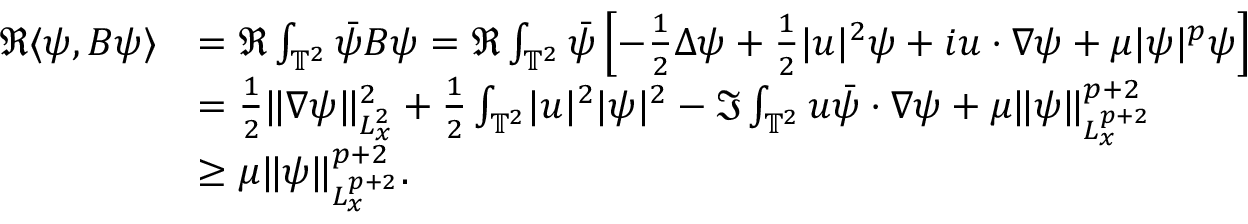<formula> <loc_0><loc_0><loc_500><loc_500>\begin{array} { r l } { \Re \langle \psi , B \psi \rangle } & { = \Re \int _ { \mathbb { T } ^ { 2 } } \ B a r { \psi } B \psi = \Re \int _ { \mathbb { T } ^ { 2 } } \ B a r { \psi } \left [ - \frac { 1 } { 2 } \Delta \psi + \frac { 1 } { 2 } | u | ^ { 2 } \psi + i u \cdot \nabla \psi + \mu | \psi | ^ { p } \psi \right ] } \\ & { = \frac { 1 } { 2 } \| \nabla \psi \| _ { L _ { x } ^ { 2 } } ^ { 2 } + \frac { 1 } { 2 } \int _ { \mathbb { T } ^ { 2 } } | u | ^ { 2 } | \psi | ^ { 2 } - \Im \int _ { \mathbb { T } ^ { 2 } } u \ B a r { \psi } \cdot \nabla \psi + \mu \| \psi \| _ { L _ { x } ^ { p + 2 } } ^ { p + 2 } } \\ & { \geq \mu \| \psi \| _ { L _ { x } ^ { p + 2 } } ^ { p + 2 } . } \end{array}</formula> 